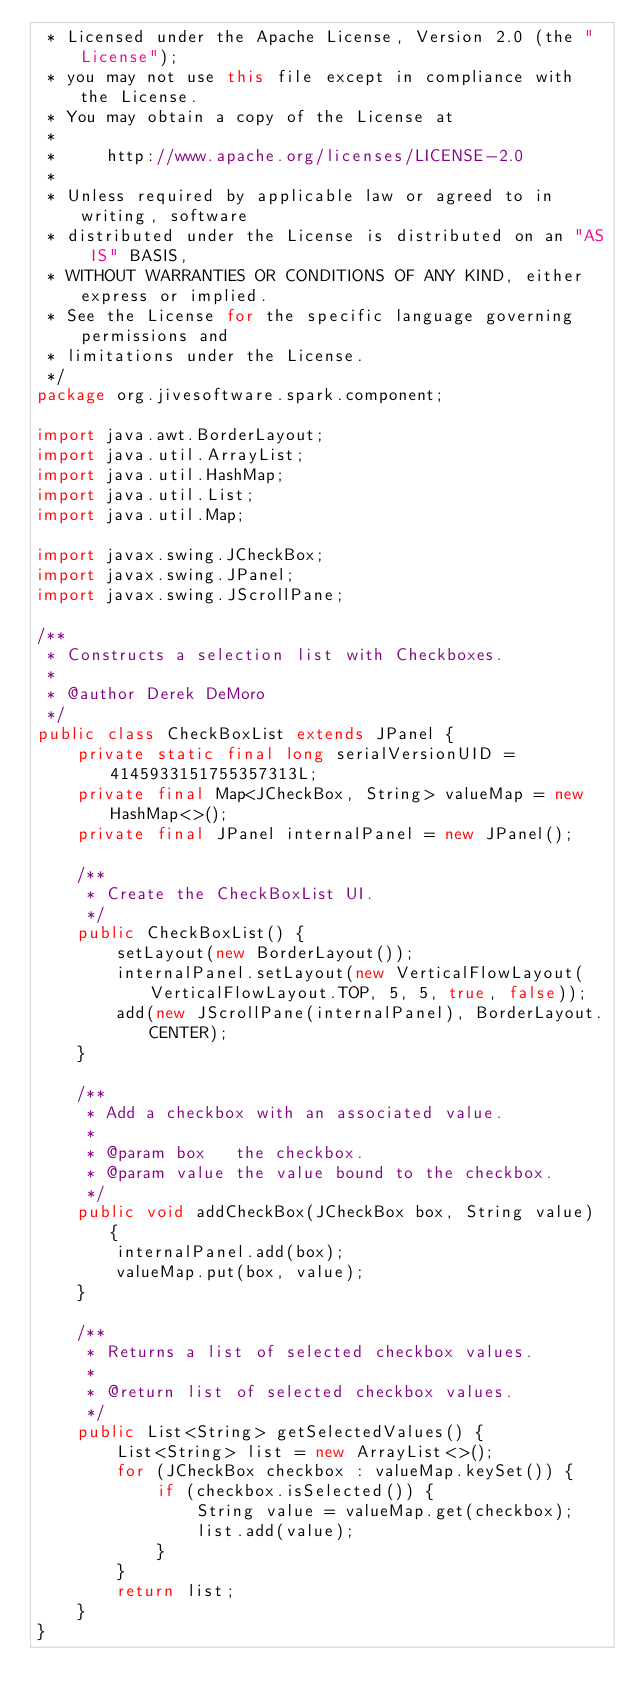<code> <loc_0><loc_0><loc_500><loc_500><_Java_> * Licensed under the Apache License, Version 2.0 (the "License");
 * you may not use this file except in compliance with the License.
 * You may obtain a copy of the License at
 *
 *     http://www.apache.org/licenses/LICENSE-2.0
 *
 * Unless required by applicable law or agreed to in writing, software
 * distributed under the License is distributed on an "AS IS" BASIS,
 * WITHOUT WARRANTIES OR CONDITIONS OF ANY KIND, either express or implied.
 * See the License for the specific language governing permissions and
 * limitations under the License.
 */
package org.jivesoftware.spark.component;

import java.awt.BorderLayout;
import java.util.ArrayList;
import java.util.HashMap;
import java.util.List;
import java.util.Map;

import javax.swing.JCheckBox;
import javax.swing.JPanel;
import javax.swing.JScrollPane;

/**
 * Constructs a selection list with Checkboxes.
 *
 * @author Derek DeMoro
 */
public class CheckBoxList extends JPanel {
    private static final long serialVersionUID = 4145933151755357313L;
    private final Map<JCheckBox, String> valueMap = new HashMap<>();
    private final JPanel internalPanel = new JPanel();

    /**
     * Create the CheckBoxList UI.
     */
    public CheckBoxList() {
        setLayout(new BorderLayout());
        internalPanel.setLayout(new VerticalFlowLayout(VerticalFlowLayout.TOP, 5, 5, true, false));
        add(new JScrollPane(internalPanel), BorderLayout.CENTER);
    }

    /**
     * Add a checkbox with an associated value.
     *
     * @param box   the checkbox.
     * @param value the value bound to the checkbox.
     */
    public void addCheckBox(JCheckBox box, String value) {
        internalPanel.add(box);
        valueMap.put(box, value);
    }

    /**
     * Returns a list of selected checkbox values.
     *
     * @return list of selected checkbox values.
     */
    public List<String> getSelectedValues() {
        List<String> list = new ArrayList<>();
        for (JCheckBox checkbox : valueMap.keySet()) {
            if (checkbox.isSelected()) {
                String value = valueMap.get(checkbox);
                list.add(value);
            }
        }
        return list;
    }
}
</code> 